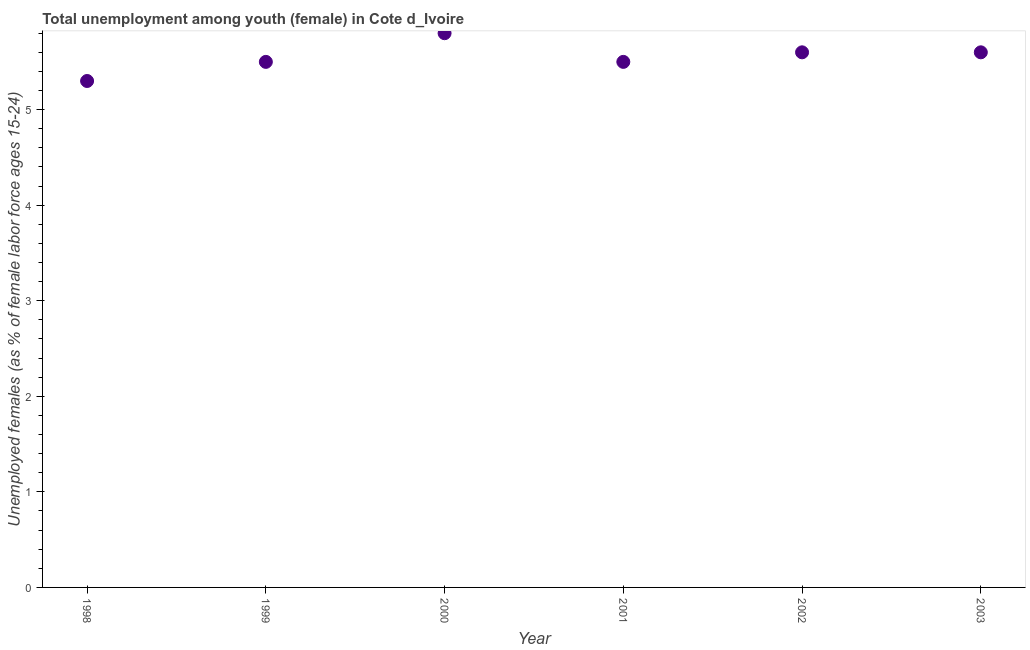Across all years, what is the maximum unemployed female youth population?
Make the answer very short. 5.8. Across all years, what is the minimum unemployed female youth population?
Your answer should be compact. 5.3. In which year was the unemployed female youth population minimum?
Ensure brevity in your answer.  1998. What is the sum of the unemployed female youth population?
Offer a very short reply. 33.3. What is the difference between the unemployed female youth population in 1998 and 2000?
Make the answer very short. -0.5. What is the average unemployed female youth population per year?
Your answer should be very brief. 5.55. What is the median unemployed female youth population?
Give a very brief answer. 5.55. In how many years, is the unemployed female youth population greater than 1.6 %?
Keep it short and to the point. 6. What is the ratio of the unemployed female youth population in 1999 to that in 2001?
Keep it short and to the point. 1. Is the unemployed female youth population in 1999 less than that in 2002?
Your response must be concise. Yes. Is the difference between the unemployed female youth population in 1999 and 2000 greater than the difference between any two years?
Keep it short and to the point. No. What is the difference between the highest and the second highest unemployed female youth population?
Your answer should be compact. 0.2. Is the sum of the unemployed female youth population in 1998 and 2002 greater than the maximum unemployed female youth population across all years?
Provide a short and direct response. Yes. What is the difference between the highest and the lowest unemployed female youth population?
Make the answer very short. 0.5. How many years are there in the graph?
Make the answer very short. 6. What is the difference between two consecutive major ticks on the Y-axis?
Make the answer very short. 1. Are the values on the major ticks of Y-axis written in scientific E-notation?
Keep it short and to the point. No. Does the graph contain any zero values?
Offer a terse response. No. What is the title of the graph?
Offer a terse response. Total unemployment among youth (female) in Cote d_Ivoire. What is the label or title of the X-axis?
Ensure brevity in your answer.  Year. What is the label or title of the Y-axis?
Provide a short and direct response. Unemployed females (as % of female labor force ages 15-24). What is the Unemployed females (as % of female labor force ages 15-24) in 1998?
Make the answer very short. 5.3. What is the Unemployed females (as % of female labor force ages 15-24) in 2000?
Provide a short and direct response. 5.8. What is the Unemployed females (as % of female labor force ages 15-24) in 2001?
Offer a very short reply. 5.5. What is the Unemployed females (as % of female labor force ages 15-24) in 2002?
Provide a succinct answer. 5.6. What is the Unemployed females (as % of female labor force ages 15-24) in 2003?
Give a very brief answer. 5.6. What is the difference between the Unemployed females (as % of female labor force ages 15-24) in 1998 and 1999?
Give a very brief answer. -0.2. What is the difference between the Unemployed females (as % of female labor force ages 15-24) in 1998 and 2000?
Your answer should be compact. -0.5. What is the difference between the Unemployed females (as % of female labor force ages 15-24) in 1998 and 2001?
Provide a short and direct response. -0.2. What is the difference between the Unemployed females (as % of female labor force ages 15-24) in 1999 and 2001?
Keep it short and to the point. 0. What is the difference between the Unemployed females (as % of female labor force ages 15-24) in 2000 and 2001?
Make the answer very short. 0.3. What is the difference between the Unemployed females (as % of female labor force ages 15-24) in 2000 and 2003?
Provide a succinct answer. 0.2. What is the difference between the Unemployed females (as % of female labor force ages 15-24) in 2002 and 2003?
Offer a terse response. 0. What is the ratio of the Unemployed females (as % of female labor force ages 15-24) in 1998 to that in 1999?
Offer a terse response. 0.96. What is the ratio of the Unemployed females (as % of female labor force ages 15-24) in 1998 to that in 2000?
Make the answer very short. 0.91. What is the ratio of the Unemployed females (as % of female labor force ages 15-24) in 1998 to that in 2002?
Give a very brief answer. 0.95. What is the ratio of the Unemployed females (as % of female labor force ages 15-24) in 1998 to that in 2003?
Your answer should be very brief. 0.95. What is the ratio of the Unemployed females (as % of female labor force ages 15-24) in 1999 to that in 2000?
Offer a very short reply. 0.95. What is the ratio of the Unemployed females (as % of female labor force ages 15-24) in 1999 to that in 2001?
Give a very brief answer. 1. What is the ratio of the Unemployed females (as % of female labor force ages 15-24) in 1999 to that in 2003?
Your answer should be compact. 0.98. What is the ratio of the Unemployed females (as % of female labor force ages 15-24) in 2000 to that in 2001?
Your answer should be very brief. 1.05. What is the ratio of the Unemployed females (as % of female labor force ages 15-24) in 2000 to that in 2002?
Keep it short and to the point. 1.04. What is the ratio of the Unemployed females (as % of female labor force ages 15-24) in 2000 to that in 2003?
Make the answer very short. 1.04. What is the ratio of the Unemployed females (as % of female labor force ages 15-24) in 2001 to that in 2002?
Make the answer very short. 0.98. What is the ratio of the Unemployed females (as % of female labor force ages 15-24) in 2001 to that in 2003?
Provide a short and direct response. 0.98. 